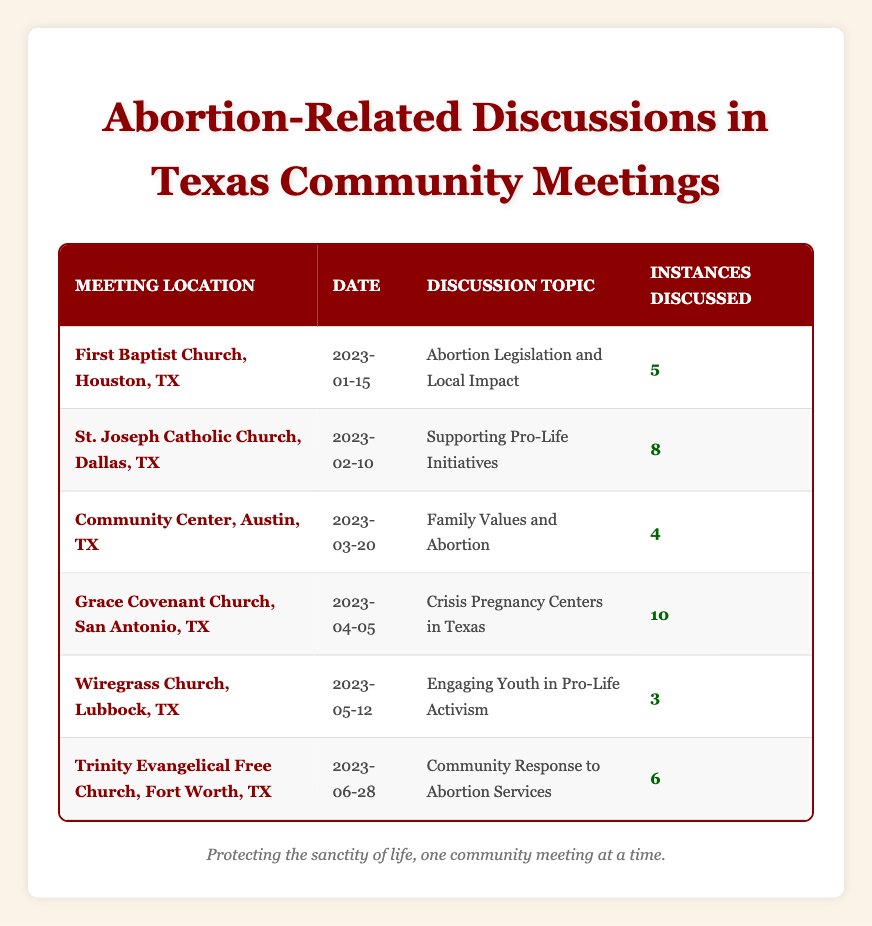What is the highest number of instances discussed in a single meeting? The table shows multiple meetings with different numbers of instances discussed. By scanning through the "Instances Discussed" column, Grace Covenant Church has the highest number at 10 instances discussed.
Answer: 10 Which meeting had the least number of instances discussed? Examining the "Instances Discussed" column, the lowest number is 3 instances during the meeting at Wiregrass Church.
Answer: 3 How many meetings discussed the topic of pro-life activism? The meetings at St. Joseph Catholic Church and Wiregrass Church mentioned pro-life activism either in their discussion topic or support for pro-life initiatives. That totals to 2 meetings.
Answer: 2 What is the average number of instances discussed across all meetings? To find the average, sum the instances (5 + 8 + 4 + 10 + 3 + 6 = 36) and divide by the number of meetings (6): 36/6 = 6.
Answer: 6 Did any meeting have a discussion topic that explicitly mentioned family values? Yes, the meeting at the Community Center in Austin explicitly mentioned "Family Values and Abortion" in its discussion topic.
Answer: Yes What is the combined total of instances discussed at both the First Baptist Church and Trinity Evangelical Free Church? First Baptist Church discussed 5 instances and Trinity Evangelical Free Church discussed 6 instances. Adding both gives: 5 + 6 = 11.
Answer: 11 How many meetings took place in the month of April? By reviewing the "Meeting Date" column, only one meeting took place in April (Grace Covenant Church on April 5, 2023).
Answer: 1 Was the discussion on abortion services more frequently mentioned than family values topics? The highest instance discussed for abortion services was 10 (Grace Covenant Church), while the topic related to family values had 4 instances (Community Center). Yes, abortion services were mentioned more frequently.
Answer: Yes Find the difference in instances discussed between the meeting with the most instances and the meeting with the fewest. The highest instances were 10 (Grace Covenant Church) and the lowest were 3 (Wiregrass Church). The difference is calculated as 10 - 3 = 7.
Answer: 7 